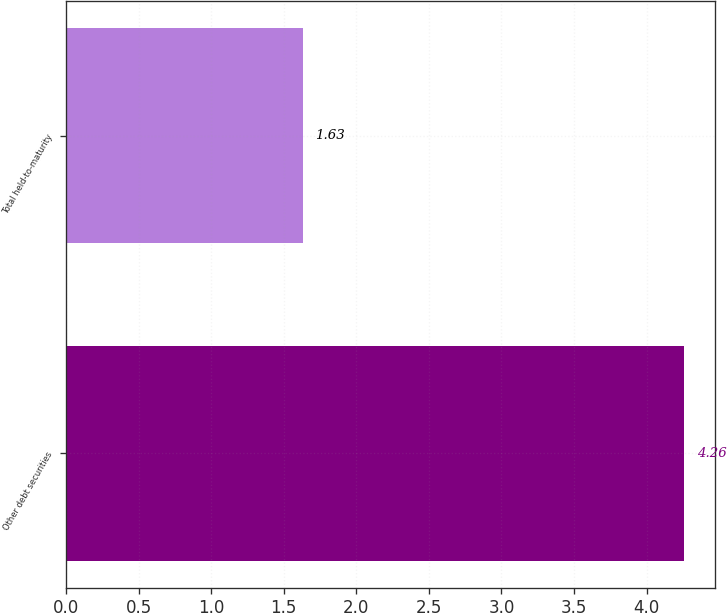Convert chart. <chart><loc_0><loc_0><loc_500><loc_500><bar_chart><fcel>Other debt securities<fcel>Total held-to-maturity<nl><fcel>4.26<fcel>1.63<nl></chart> 